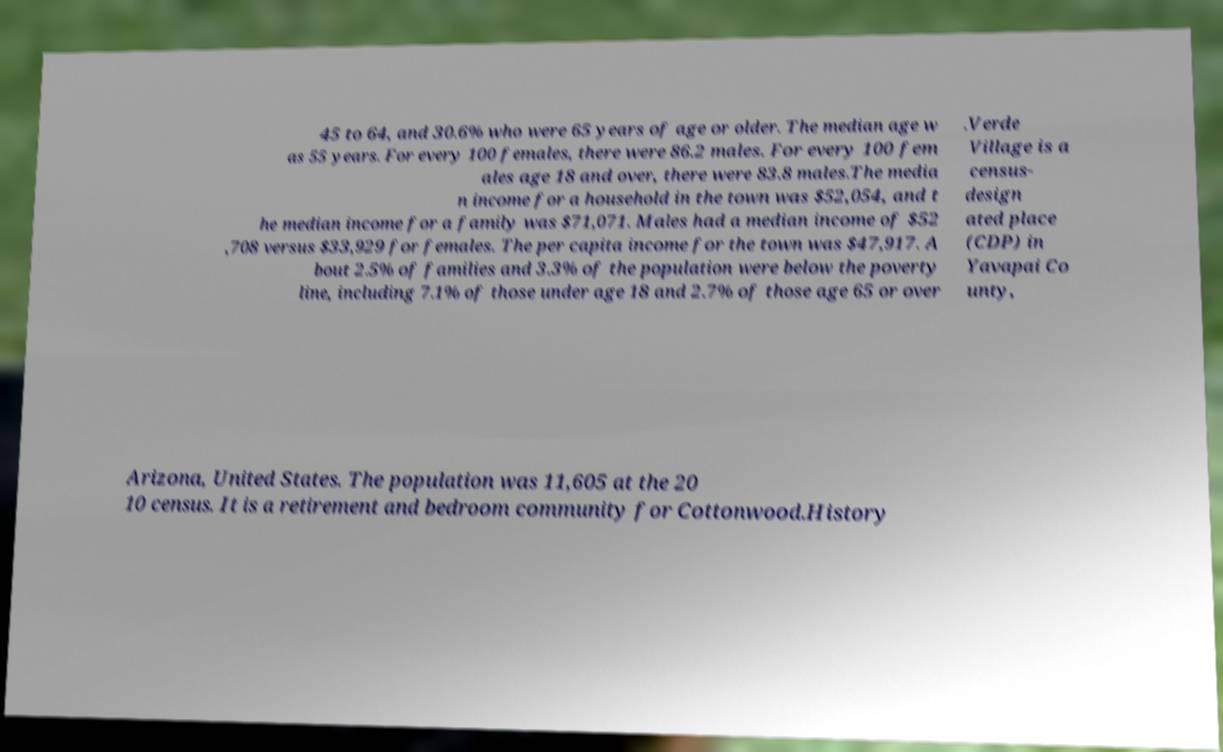Could you assist in decoding the text presented in this image and type it out clearly? 45 to 64, and 30.6% who were 65 years of age or older. The median age w as 55 years. For every 100 females, there were 86.2 males. For every 100 fem ales age 18 and over, there were 83.8 males.The media n income for a household in the town was $52,054, and t he median income for a family was $71,071. Males had a median income of $52 ,708 versus $33,929 for females. The per capita income for the town was $47,917. A bout 2.5% of families and 3.3% of the population were below the poverty line, including 7.1% of those under age 18 and 2.7% of those age 65 or over .Verde Village is a census- design ated place (CDP) in Yavapai Co unty, Arizona, United States. The population was 11,605 at the 20 10 census. It is a retirement and bedroom community for Cottonwood.History 